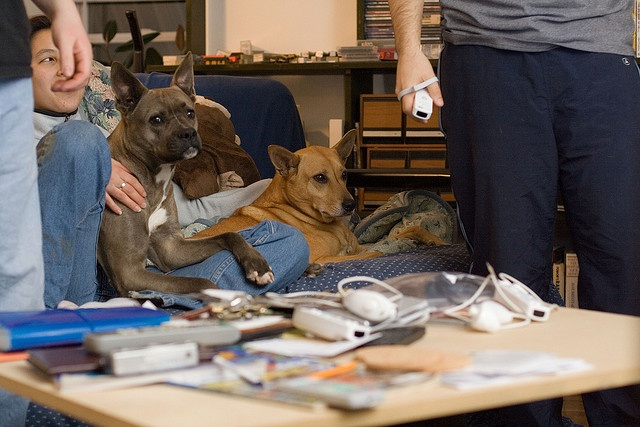Describe the objects in this image and their specific colors. I can see dining table in black, tan, lightgray, and darkgray tones, people in black and gray tones, dog in black, maroon, and gray tones, people in black, gray, and blue tones, and people in black, darkgray, and tan tones in this image. 